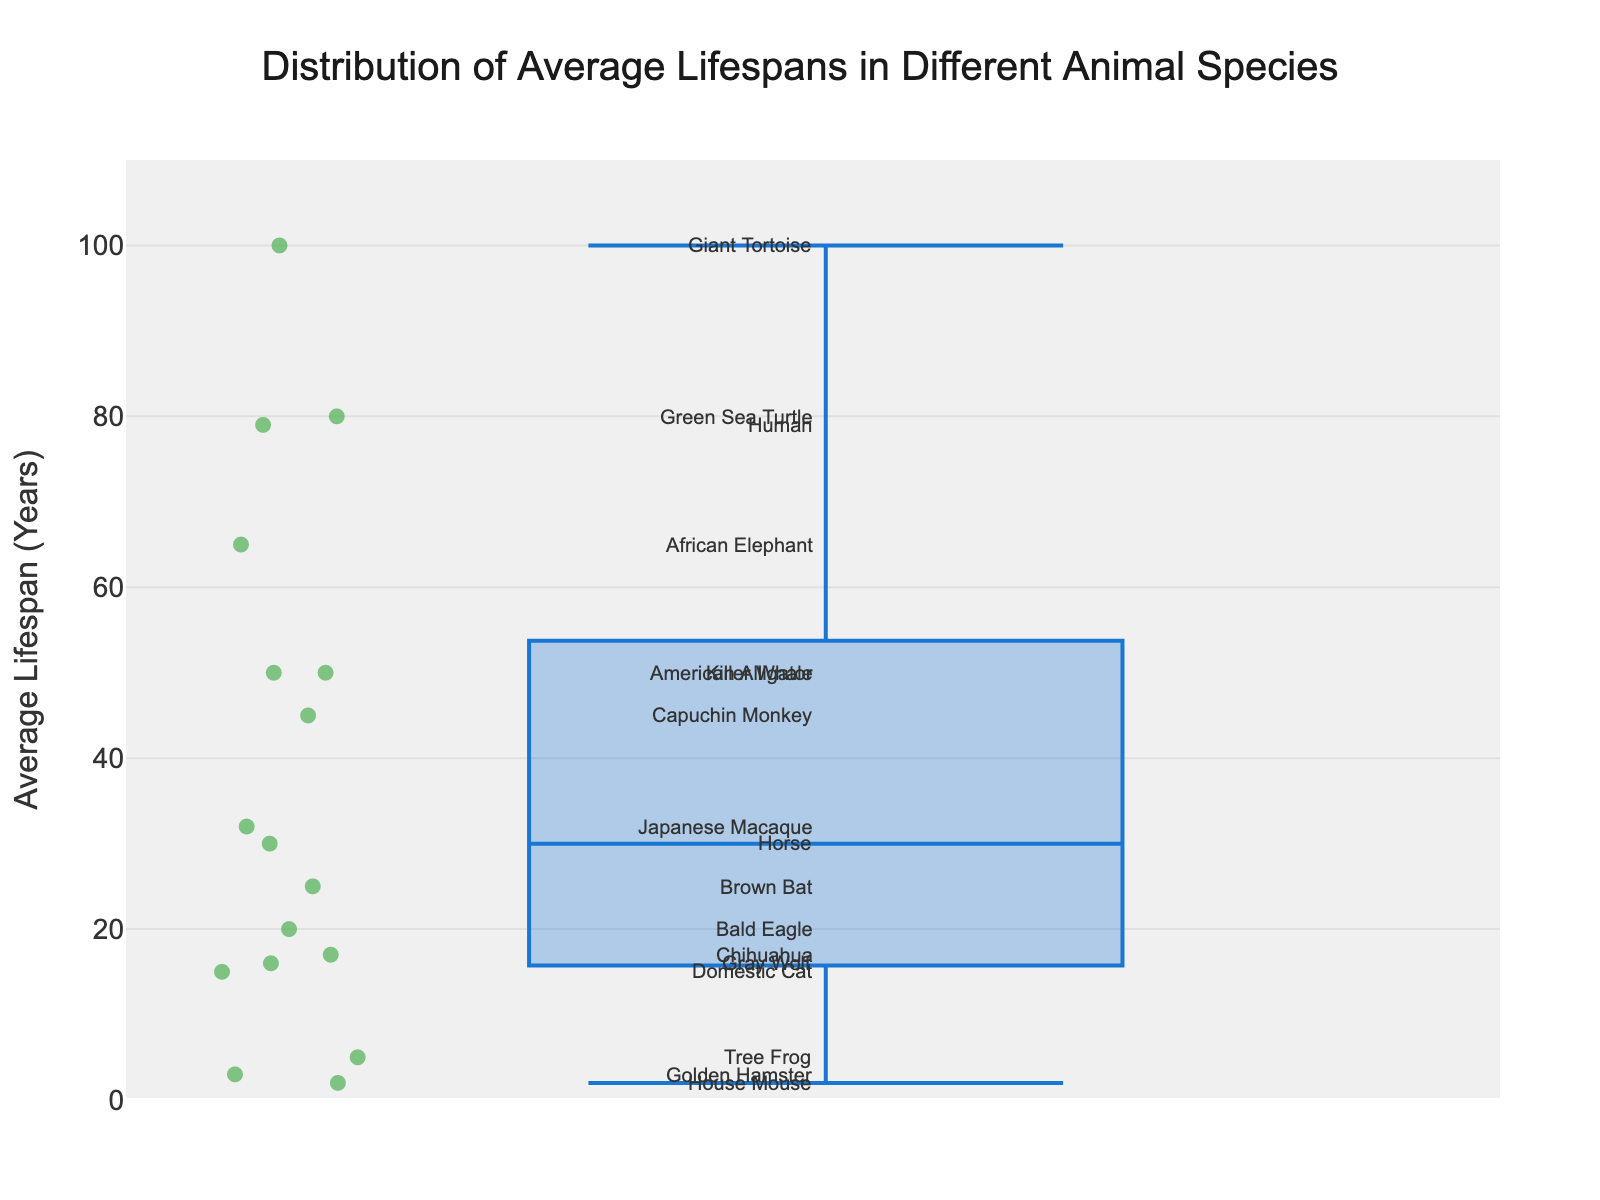What is the title of the box plot? The title is located at the top center of the figure. It is in larger, bold font and describes the overall subject of the visualized data.
Answer: Distribution of Average Lifespans in Different Animal Species What is the shortest average lifespan among the animal species in the box plot? To find this, look for the lowest data point on the y-axis.
Answer: House Mouse (2 years) Which species has the longest average lifespan according to the box plot? To identify this, find the highest data point on the y-axis.
Answer: Giant Tortoise (100 years) What is the median average lifespan shown in the box plot? The median is indicated by a line within the box of the box plot. Look at its position on the y-axis and identify the corresponding value.
Answer: Approximately 30 years What are the interquartile range (IQR) values for the box plot? Identify the bottom and top of the box; these represent the 25th and 75th percentiles, respectively. Subtract the 25th percentile value from the 75th percentile value to find the IQR. Based on the y-axis values, this can be approximated or read directly if available.
Answer: Approximately 16 years (upper at ~45, lower at ~29) Which species' average lifespan is closest to the 75th percentile of the data? Identify the 75th percentile value on the plot (the top of the box) and see which species' data point is closest to that value on the y-axis.
Answer: Capuchin Monkey (45 years) How many species have an average lifespan above 50 years? Count all data points that lie above the 50-year mark on the y-axis. Verify each species' label to ensure accuracy.
Answer: Four (African Elephant, American Alligator, Green Sea Turtle, Giant Tortoise) Which species has an average lifespan similar to the median human lifespan? Examine the data points and identify which corresponds closely with the human lifespan.
Answer: Human (79 years) How does the average lifespan of the Bald Eagle compare to that of the Brown Bat? Look at the y-axis values for both the Bald Eagle and the Brown Bat, then compare their positions.
Answer: The Bald Eagle (20 years) has a shorter lifespan than the Brown Bat (25 years) What is the range of average lifespans presented in the data? Calculate the range by subtracting the shortest lifespan from the longest lifespan noted in the box plot.
Answer: 98 years (100 - 2) 